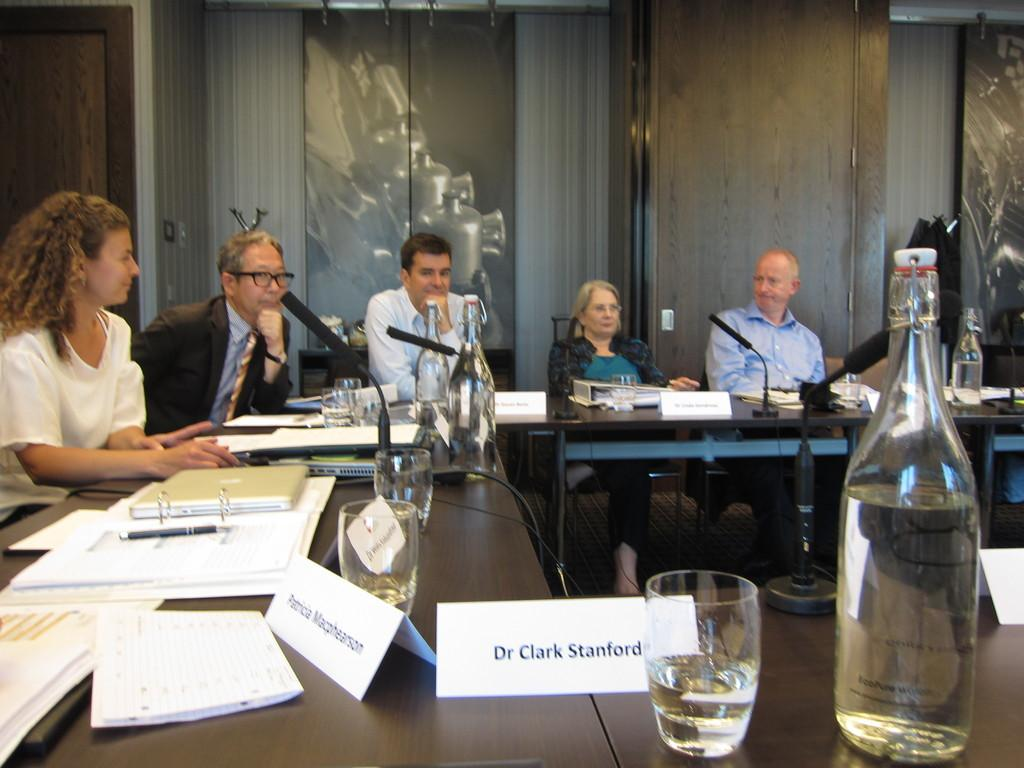<image>
Present a compact description of the photo's key features. a dr. clark stanford name tag on the desk 